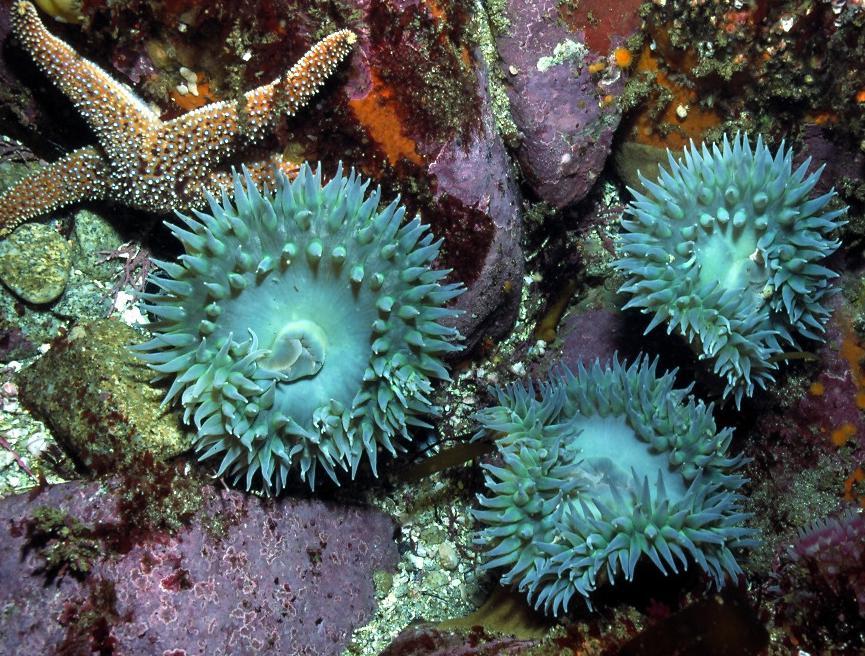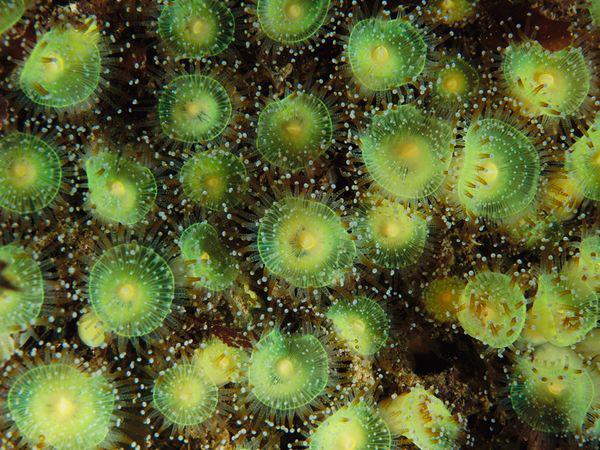The first image is the image on the left, the second image is the image on the right. Examine the images to the left and right. Is the description "There are more sea organisms in the image on the left." accurate? Answer yes or no. No. The first image is the image on the left, the second image is the image on the right. Evaluate the accuracy of this statement regarding the images: "Each image features lime-green anemone with tapered tendrils, and at least one image contains a single lime-green anemone.". Is it true? Answer yes or no. No. 